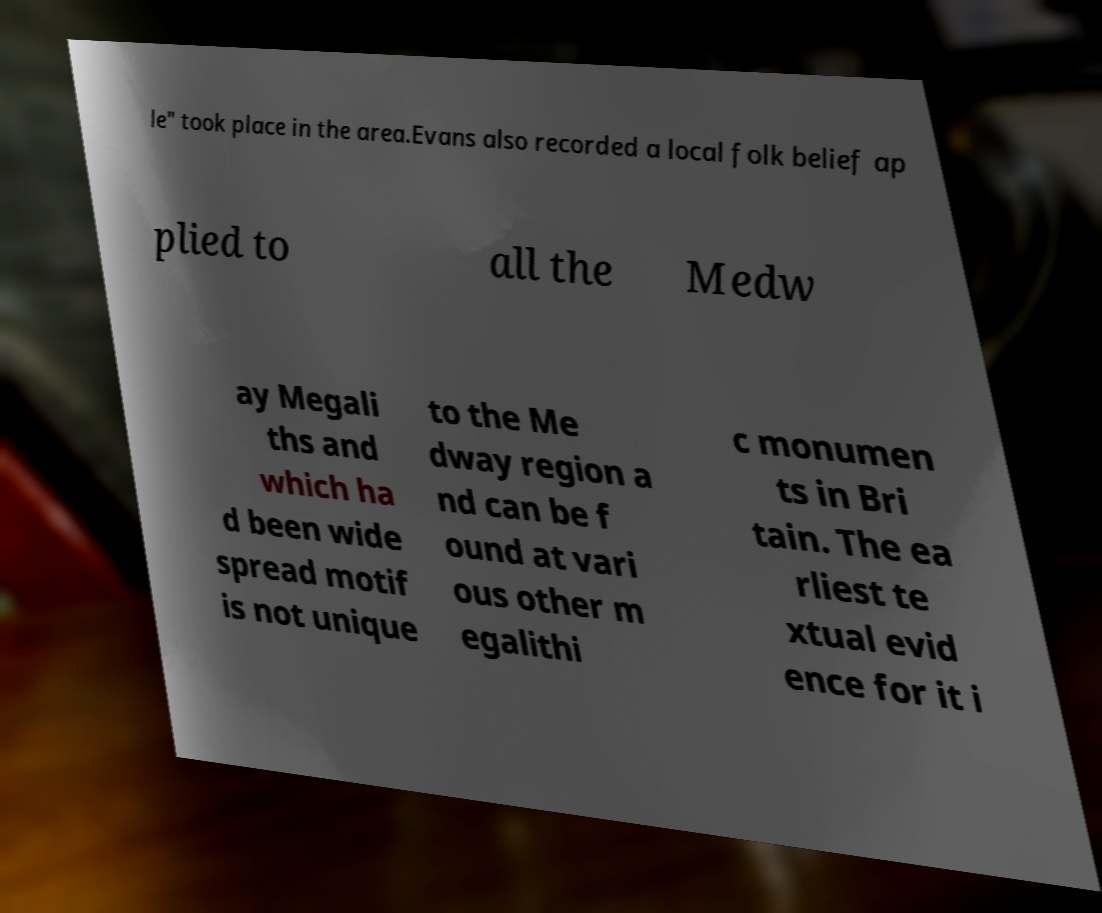Please identify and transcribe the text found in this image. le" took place in the area.Evans also recorded a local folk belief ap plied to all the Medw ay Megali ths and which ha d been wide spread motif is not unique to the Me dway region a nd can be f ound at vari ous other m egalithi c monumen ts in Bri tain. The ea rliest te xtual evid ence for it i 